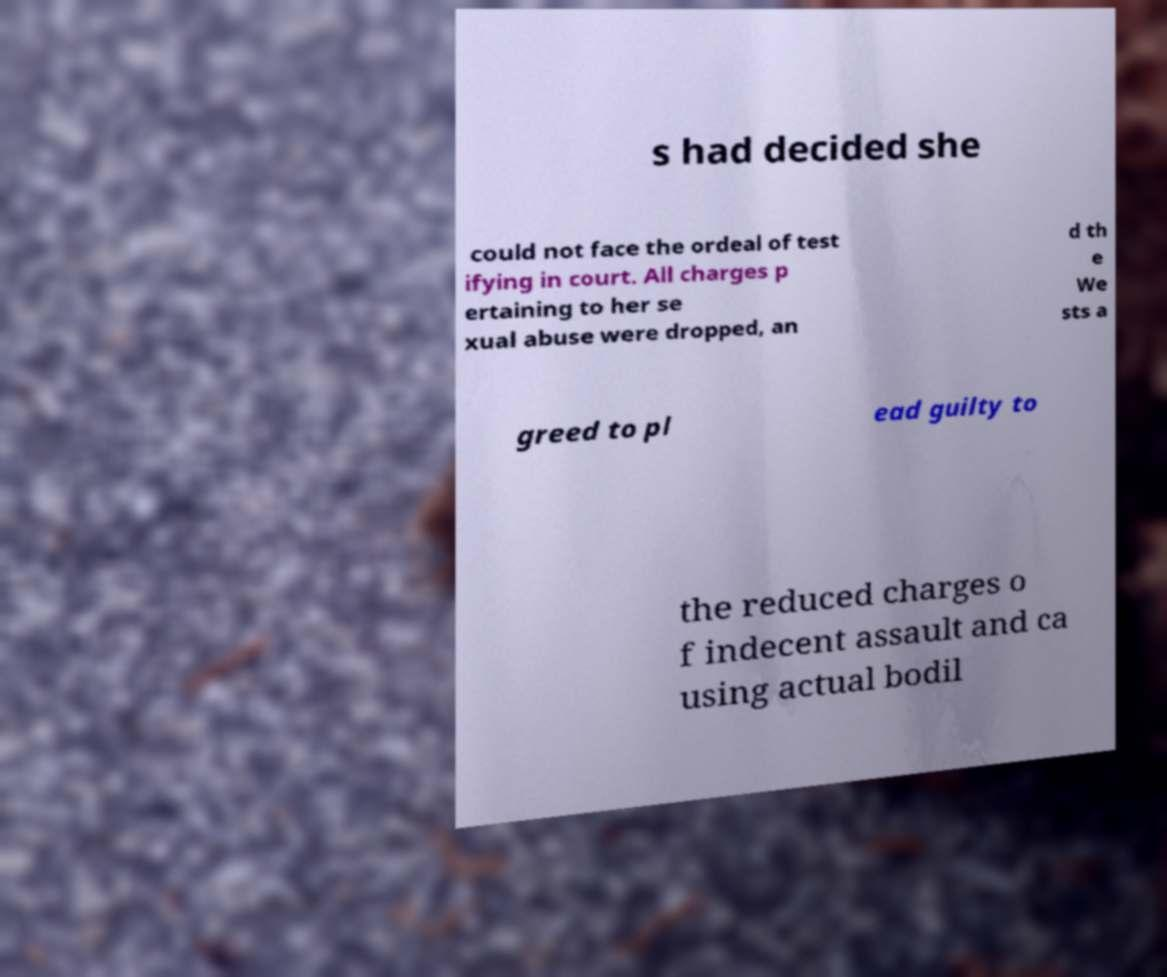There's text embedded in this image that I need extracted. Can you transcribe it verbatim? s had decided she could not face the ordeal of test ifying in court. All charges p ertaining to her se xual abuse were dropped, an d th e We sts a greed to pl ead guilty to the reduced charges o f indecent assault and ca using actual bodil 